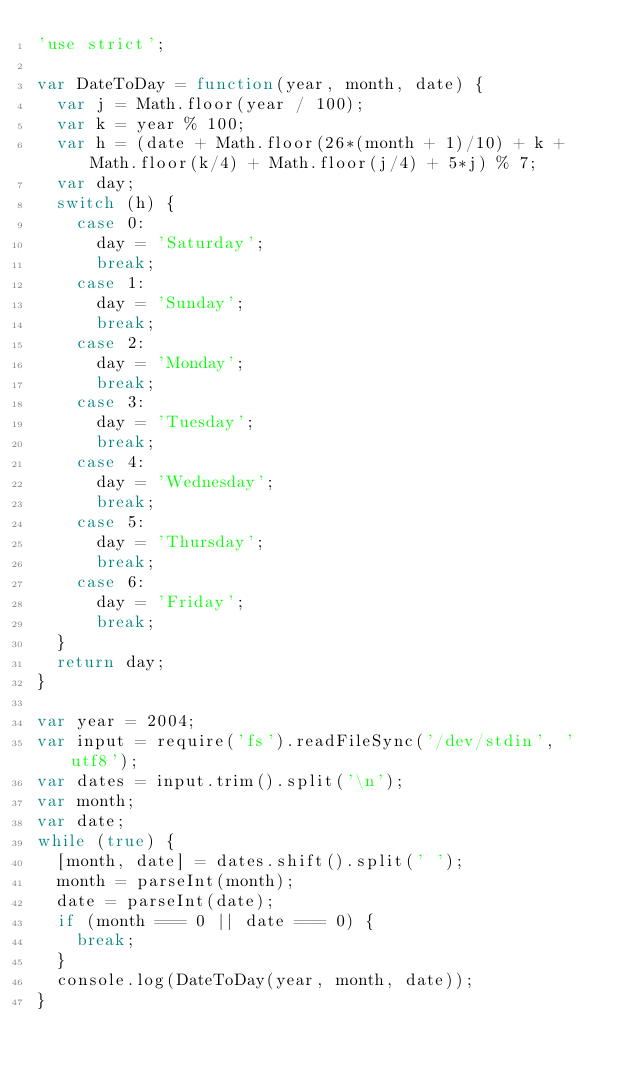Convert code to text. <code><loc_0><loc_0><loc_500><loc_500><_JavaScript_>'use strict';

var DateToDay = function(year, month, date) {
	var j = Math.floor(year / 100);
	var k = year % 100;
	var h = (date + Math.floor(26*(month + 1)/10) + k + Math.floor(k/4) + Math.floor(j/4) + 5*j) % 7;
	var day;
	switch (h) {
		case 0:
			day = 'Saturday';
			break;
		case 1:
			day = 'Sunday';
			break;
		case 2:
			day = 'Monday';
			break;
		case 3:
			day = 'Tuesday';
			break;
		case 4:
			day = 'Wednesday';
			break;
		case 5:
			day = 'Thursday';
			break;
		case 6:
			day = 'Friday';
			break;
	}
	return day;
}

var year = 2004;
var input = require('fs').readFileSync('/dev/stdin', 'utf8');
var dates = input.trim().split('\n');
var month;
var date;
while (true) {
	[month, date] = dates.shift().split(' ');
	month = parseInt(month);
	date = parseInt(date);
	if (month === 0 || date === 0) {
		break;
	}
	console.log(DateToDay(year, month, date));
}</code> 